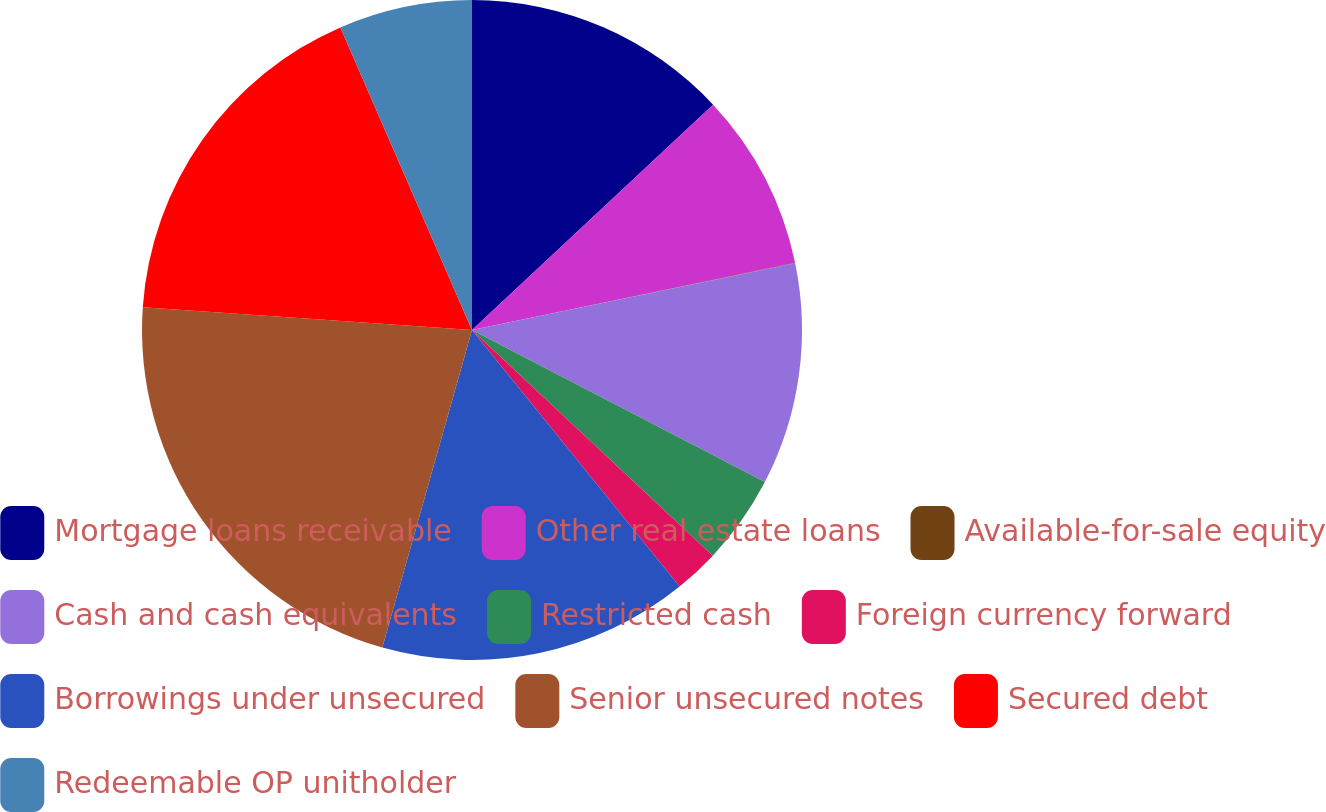Convert chart to OTSL. <chart><loc_0><loc_0><loc_500><loc_500><pie_chart><fcel>Mortgage loans receivable<fcel>Other real estate loans<fcel>Available-for-sale equity<fcel>Cash and cash equivalents<fcel>Restricted cash<fcel>Foreign currency forward<fcel>Borrowings under unsecured<fcel>Senior unsecured notes<fcel>Secured debt<fcel>Redeemable OP unitholder<nl><fcel>13.04%<fcel>8.7%<fcel>0.02%<fcel>10.87%<fcel>4.36%<fcel>2.19%<fcel>15.21%<fcel>21.72%<fcel>17.38%<fcel>6.53%<nl></chart> 